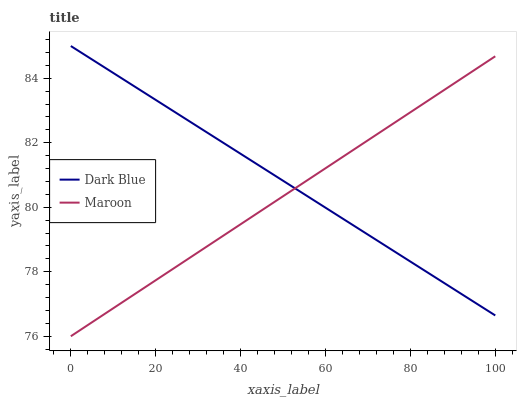Does Maroon have the minimum area under the curve?
Answer yes or no. Yes. Does Dark Blue have the maximum area under the curve?
Answer yes or no. Yes. Does Maroon have the maximum area under the curve?
Answer yes or no. No. Is Dark Blue the smoothest?
Answer yes or no. Yes. Is Maroon the roughest?
Answer yes or no. Yes. Is Maroon the smoothest?
Answer yes or no. No. Does Maroon have the lowest value?
Answer yes or no. Yes. Does Dark Blue have the highest value?
Answer yes or no. Yes. Does Maroon have the highest value?
Answer yes or no. No. Does Dark Blue intersect Maroon?
Answer yes or no. Yes. Is Dark Blue less than Maroon?
Answer yes or no. No. Is Dark Blue greater than Maroon?
Answer yes or no. No. 